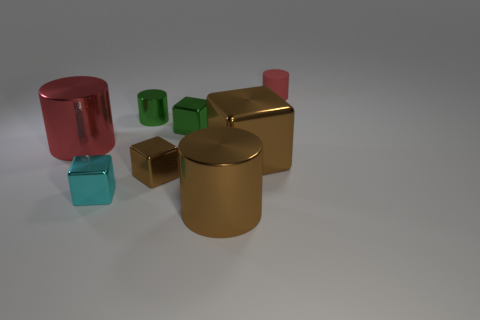Is there anything else that has the same material as the small red thing?
Your response must be concise. No. There is a metallic cube that is behind the big red shiny object; does it have the same color as the small shiny cylinder?
Keep it short and to the point. Yes. Are there any small metallic things that have the same color as the big block?
Keep it short and to the point. Yes. There is a big block; what number of tiny cylinders are right of it?
Make the answer very short. 1. How many other objects are there of the same size as the matte thing?
Your answer should be very brief. 4. Is the red cylinder left of the small rubber thing made of the same material as the tiny object on the left side of the small shiny cylinder?
Your answer should be compact. Yes. What is the color of the rubber object that is the same size as the green shiny cylinder?
Provide a succinct answer. Red. There is a red object that is left of the red cylinder behind the red cylinder on the left side of the brown shiny cylinder; how big is it?
Give a very brief answer. Large. What is the color of the cylinder that is on the right side of the green metal cube and behind the green shiny block?
Ensure brevity in your answer.  Red. There is a metal cylinder left of the green metal cylinder; what size is it?
Make the answer very short. Large. 